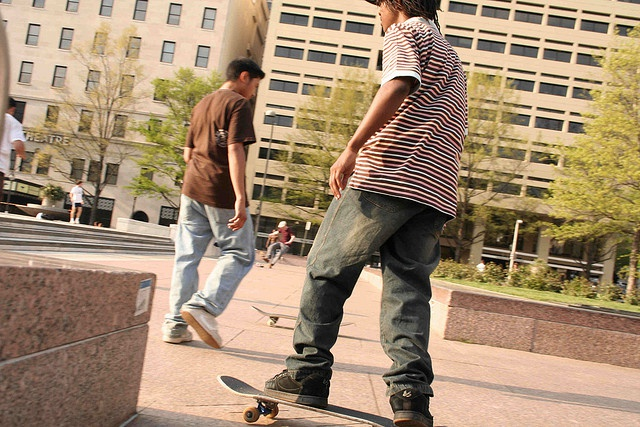Describe the objects in this image and their specific colors. I can see people in black, gray, ivory, and maroon tones, people in black, ivory, gray, and brown tones, skateboard in black, gray, and maroon tones, people in black, lightgray, and darkgray tones, and people in black, brown, gray, maroon, and tan tones in this image. 